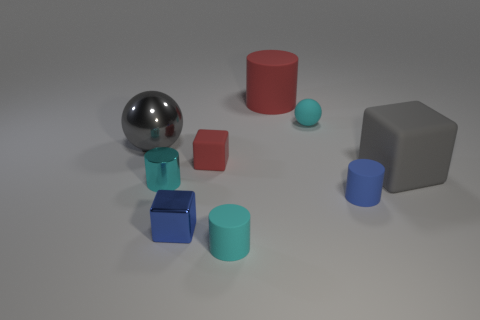What is the shape of the cyan object that is on the right side of the tiny matte cylinder that is in front of the small blue shiny block?
Give a very brief answer. Sphere. What shape is the gray shiny thing that is the same size as the gray cube?
Ensure brevity in your answer.  Sphere. Is there a tiny matte object that has the same shape as the large red matte thing?
Your response must be concise. Yes. What is the material of the large gray sphere?
Offer a very short reply. Metal. There is a big block; are there any tiny cylinders behind it?
Your answer should be very brief. No. There is a small blue object that is to the right of the cyan rubber ball; what number of blocks are behind it?
Provide a short and direct response. 2. There is a red cube that is the same size as the blue matte cylinder; what material is it?
Make the answer very short. Rubber. What number of other things are the same material as the cyan ball?
Your response must be concise. 5. What number of tiny blue metal blocks are on the left side of the blue rubber cylinder?
Keep it short and to the point. 1. What number of cylinders are tiny red things or small metal things?
Keep it short and to the point. 1. 